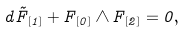<formula> <loc_0><loc_0><loc_500><loc_500>d \tilde { F } _ { [ 1 ] } + F _ { [ 0 ] } \wedge F _ { [ 2 ] } = 0 ,</formula> 